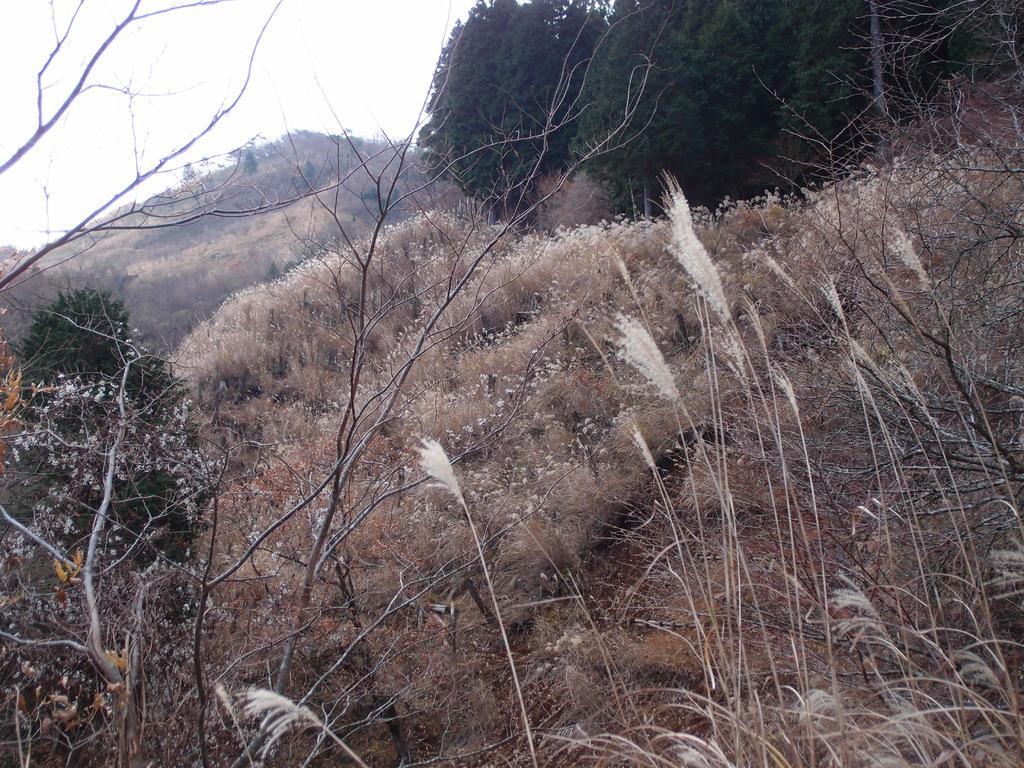Can you describe this image briefly? This image consists of plants and dry grass on the ground. In the background, there are trees. At the top, there is sky. 